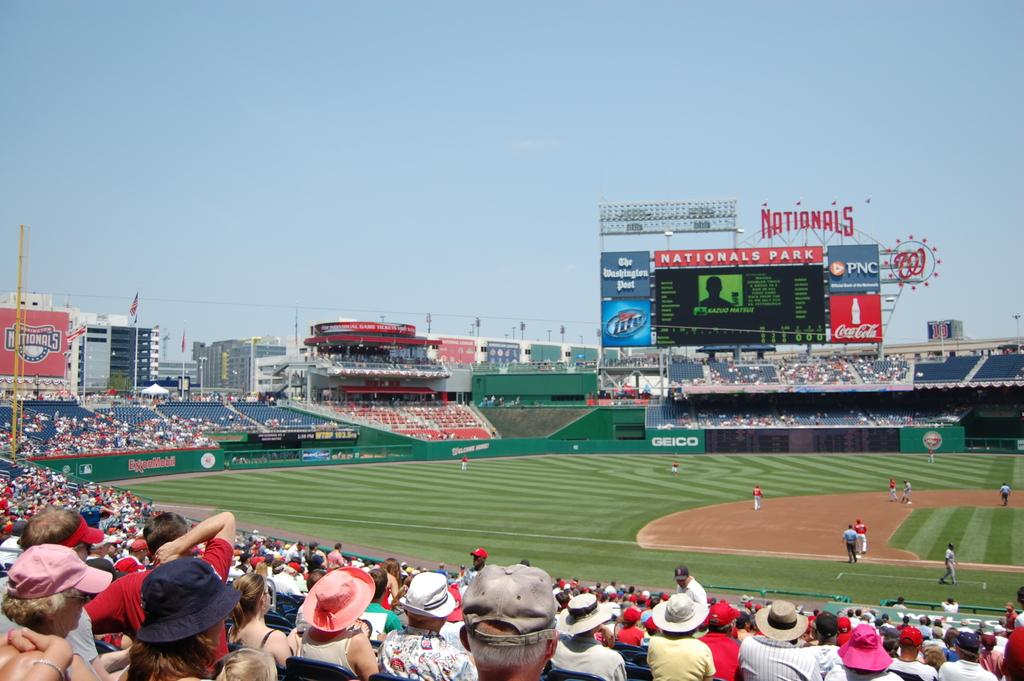<image>
Offer a succinct explanation of the picture presented. The National baseball stadium with many people in the seats. 